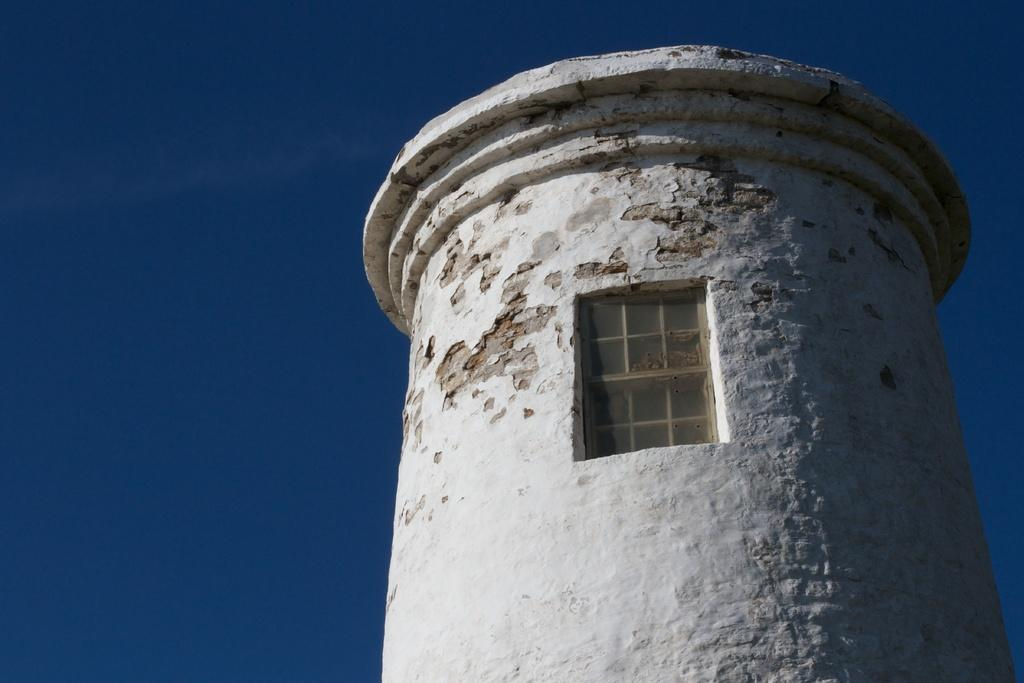What structure is depicted in the image? There is a tower in the image. What feature is present on the tower? There is a window in the image. What is visible in the background of the image? The sky is visible in the background of the image. How many brothers can be seen in the image? There are no brothers present in the image. What type of skin is visible on the tower in the image? The tower is an inanimate object and does not have skin. 